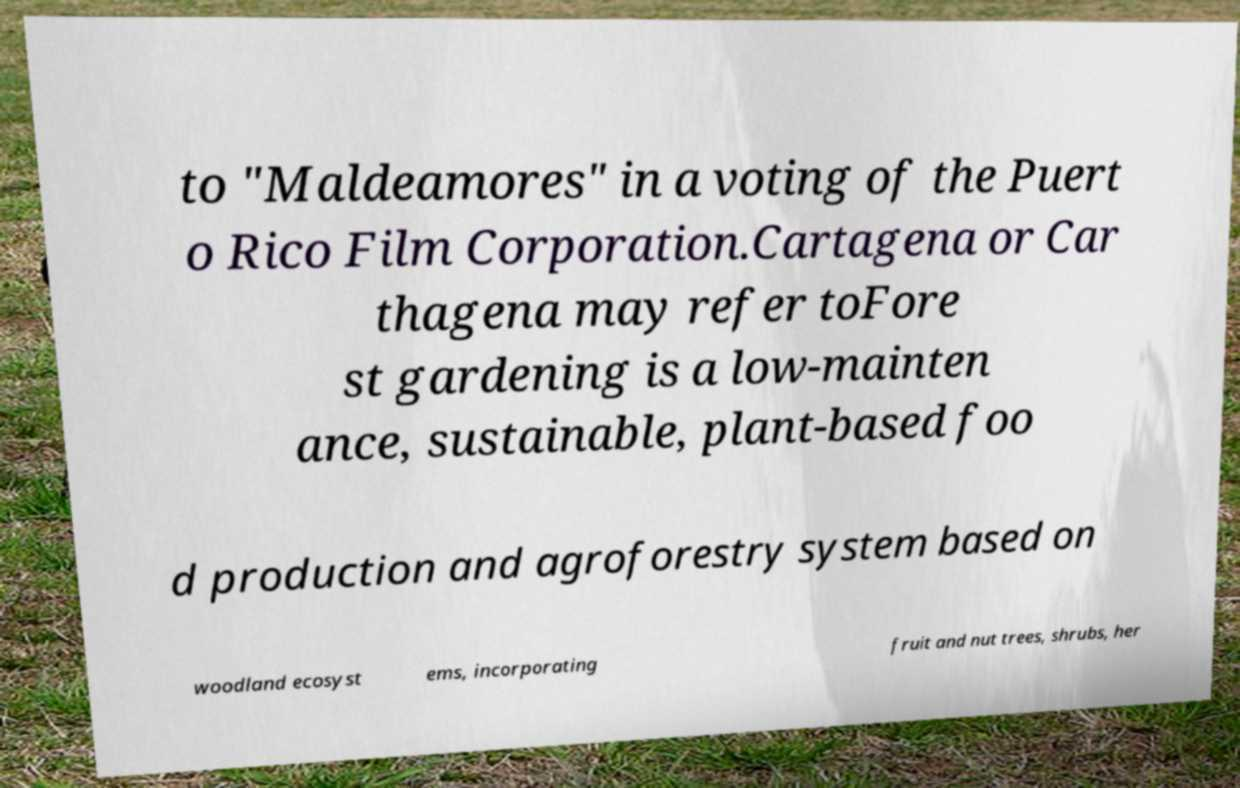Please read and relay the text visible in this image. What does it say? to "Maldeamores" in a voting of the Puert o Rico Film Corporation.Cartagena or Car thagena may refer toFore st gardening is a low-mainten ance, sustainable, plant-based foo d production and agroforestry system based on woodland ecosyst ems, incorporating fruit and nut trees, shrubs, her 